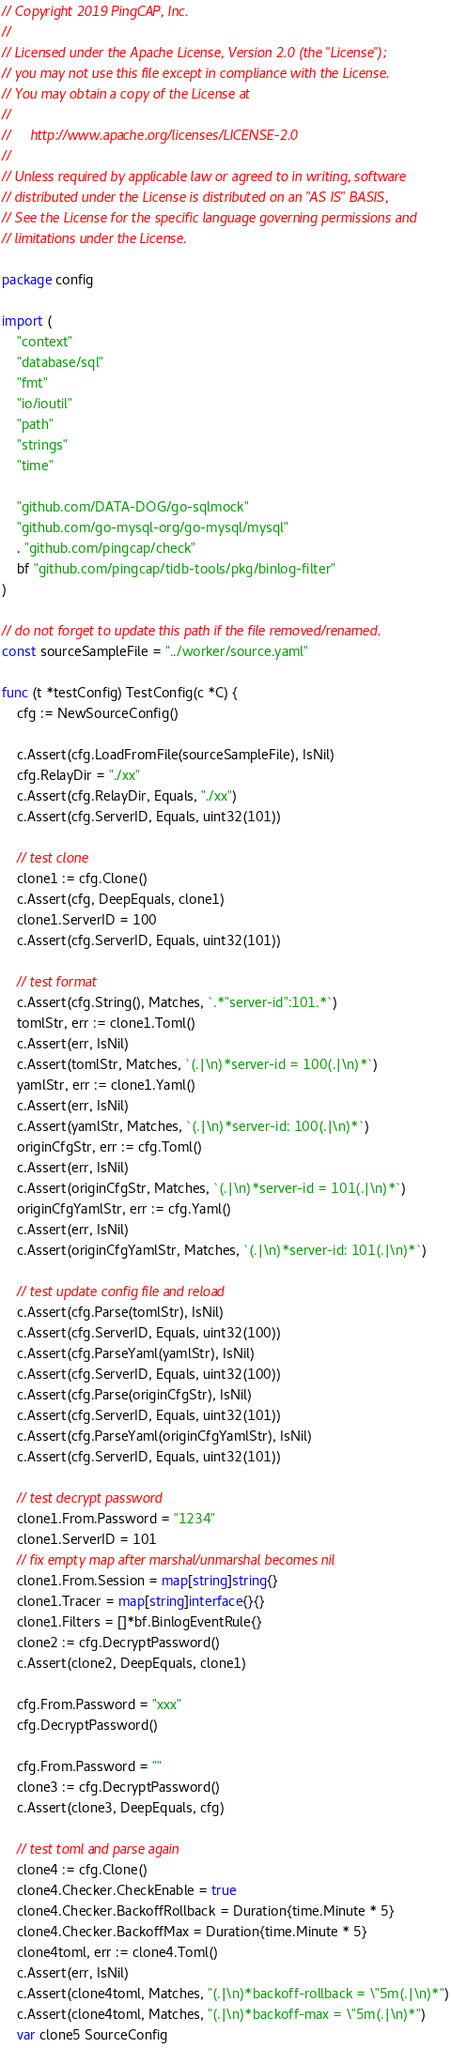Convert code to text. <code><loc_0><loc_0><loc_500><loc_500><_Go_>// Copyright 2019 PingCAP, Inc.
//
// Licensed under the Apache License, Version 2.0 (the "License");
// you may not use this file except in compliance with the License.
// You may obtain a copy of the License at
//
//     http://www.apache.org/licenses/LICENSE-2.0
//
// Unless required by applicable law or agreed to in writing, software
// distributed under the License is distributed on an "AS IS" BASIS,
// See the License for the specific language governing permissions and
// limitations under the License.

package config

import (
	"context"
	"database/sql"
	"fmt"
	"io/ioutil"
	"path"
	"strings"
	"time"

	"github.com/DATA-DOG/go-sqlmock"
	"github.com/go-mysql-org/go-mysql/mysql"
	. "github.com/pingcap/check"
	bf "github.com/pingcap/tidb-tools/pkg/binlog-filter"
)

// do not forget to update this path if the file removed/renamed.
const sourceSampleFile = "../worker/source.yaml"

func (t *testConfig) TestConfig(c *C) {
	cfg := NewSourceConfig()

	c.Assert(cfg.LoadFromFile(sourceSampleFile), IsNil)
	cfg.RelayDir = "./xx"
	c.Assert(cfg.RelayDir, Equals, "./xx")
	c.Assert(cfg.ServerID, Equals, uint32(101))

	// test clone
	clone1 := cfg.Clone()
	c.Assert(cfg, DeepEquals, clone1)
	clone1.ServerID = 100
	c.Assert(cfg.ServerID, Equals, uint32(101))

	// test format
	c.Assert(cfg.String(), Matches, `.*"server-id":101.*`)
	tomlStr, err := clone1.Toml()
	c.Assert(err, IsNil)
	c.Assert(tomlStr, Matches, `(.|\n)*server-id = 100(.|\n)*`)
	yamlStr, err := clone1.Yaml()
	c.Assert(err, IsNil)
	c.Assert(yamlStr, Matches, `(.|\n)*server-id: 100(.|\n)*`)
	originCfgStr, err := cfg.Toml()
	c.Assert(err, IsNil)
	c.Assert(originCfgStr, Matches, `(.|\n)*server-id = 101(.|\n)*`)
	originCfgYamlStr, err := cfg.Yaml()
	c.Assert(err, IsNil)
	c.Assert(originCfgYamlStr, Matches, `(.|\n)*server-id: 101(.|\n)*`)

	// test update config file and reload
	c.Assert(cfg.Parse(tomlStr), IsNil)
	c.Assert(cfg.ServerID, Equals, uint32(100))
	c.Assert(cfg.ParseYaml(yamlStr), IsNil)
	c.Assert(cfg.ServerID, Equals, uint32(100))
	c.Assert(cfg.Parse(originCfgStr), IsNil)
	c.Assert(cfg.ServerID, Equals, uint32(101))
	c.Assert(cfg.ParseYaml(originCfgYamlStr), IsNil)
	c.Assert(cfg.ServerID, Equals, uint32(101))

	// test decrypt password
	clone1.From.Password = "1234"
	clone1.ServerID = 101
	// fix empty map after marshal/unmarshal becomes nil
	clone1.From.Session = map[string]string{}
	clone1.Tracer = map[string]interface{}{}
	clone1.Filters = []*bf.BinlogEventRule{}
	clone2 := cfg.DecryptPassword()
	c.Assert(clone2, DeepEquals, clone1)

	cfg.From.Password = "xxx"
	cfg.DecryptPassword()

	cfg.From.Password = ""
	clone3 := cfg.DecryptPassword()
	c.Assert(clone3, DeepEquals, cfg)

	// test toml and parse again
	clone4 := cfg.Clone()
	clone4.Checker.CheckEnable = true
	clone4.Checker.BackoffRollback = Duration{time.Minute * 5}
	clone4.Checker.BackoffMax = Duration{time.Minute * 5}
	clone4toml, err := clone4.Toml()
	c.Assert(err, IsNil)
	c.Assert(clone4toml, Matches, "(.|\n)*backoff-rollback = \"5m(.|\n)*")
	c.Assert(clone4toml, Matches, "(.|\n)*backoff-max = \"5m(.|\n)*")
	var clone5 SourceConfig</code> 